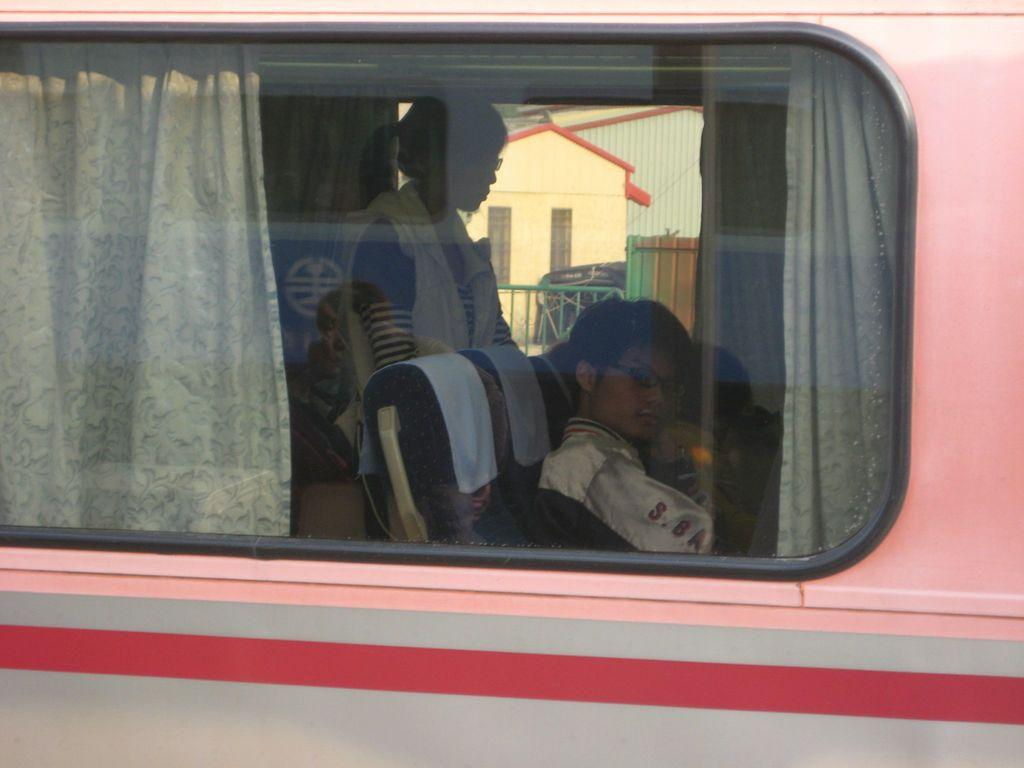What is the main subject of the image? The main subject of the image is a bus. What can be seen inside the bus? There are people sitting and standing inside the bus. What is visible in the background of the image? There is a building visible behind the bus. How many masks are being distributed by the beggar in the image? There is no beggar or distribution of masks present in the image. 